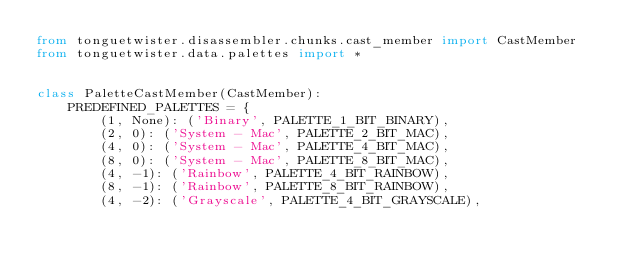Convert code to text. <code><loc_0><loc_0><loc_500><loc_500><_Python_>from tonguetwister.disassembler.chunks.cast_member import CastMember
from tonguetwister.data.palettes import *


class PaletteCastMember(CastMember):
    PREDEFINED_PALETTES = {
        (1, None): ('Binary', PALETTE_1_BIT_BINARY),
        (2, 0): ('System - Mac', PALETTE_2_BIT_MAC),
        (4, 0): ('System - Mac', PALETTE_4_BIT_MAC),
        (8, 0): ('System - Mac', PALETTE_8_BIT_MAC),
        (4, -1): ('Rainbow', PALETTE_4_BIT_RAINBOW),
        (8, -1): ('Rainbow', PALETTE_8_BIT_RAINBOW),
        (4, -2): ('Grayscale', PALETTE_4_BIT_GRAYSCALE),</code> 